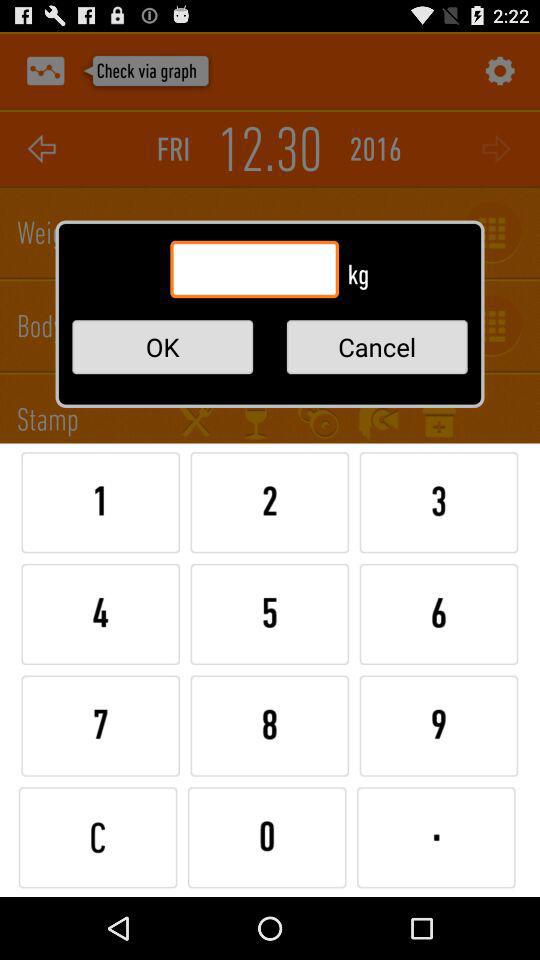What time is it reflecting on the screen?
When the provided information is insufficient, respond with <no answer>. <no answer> 